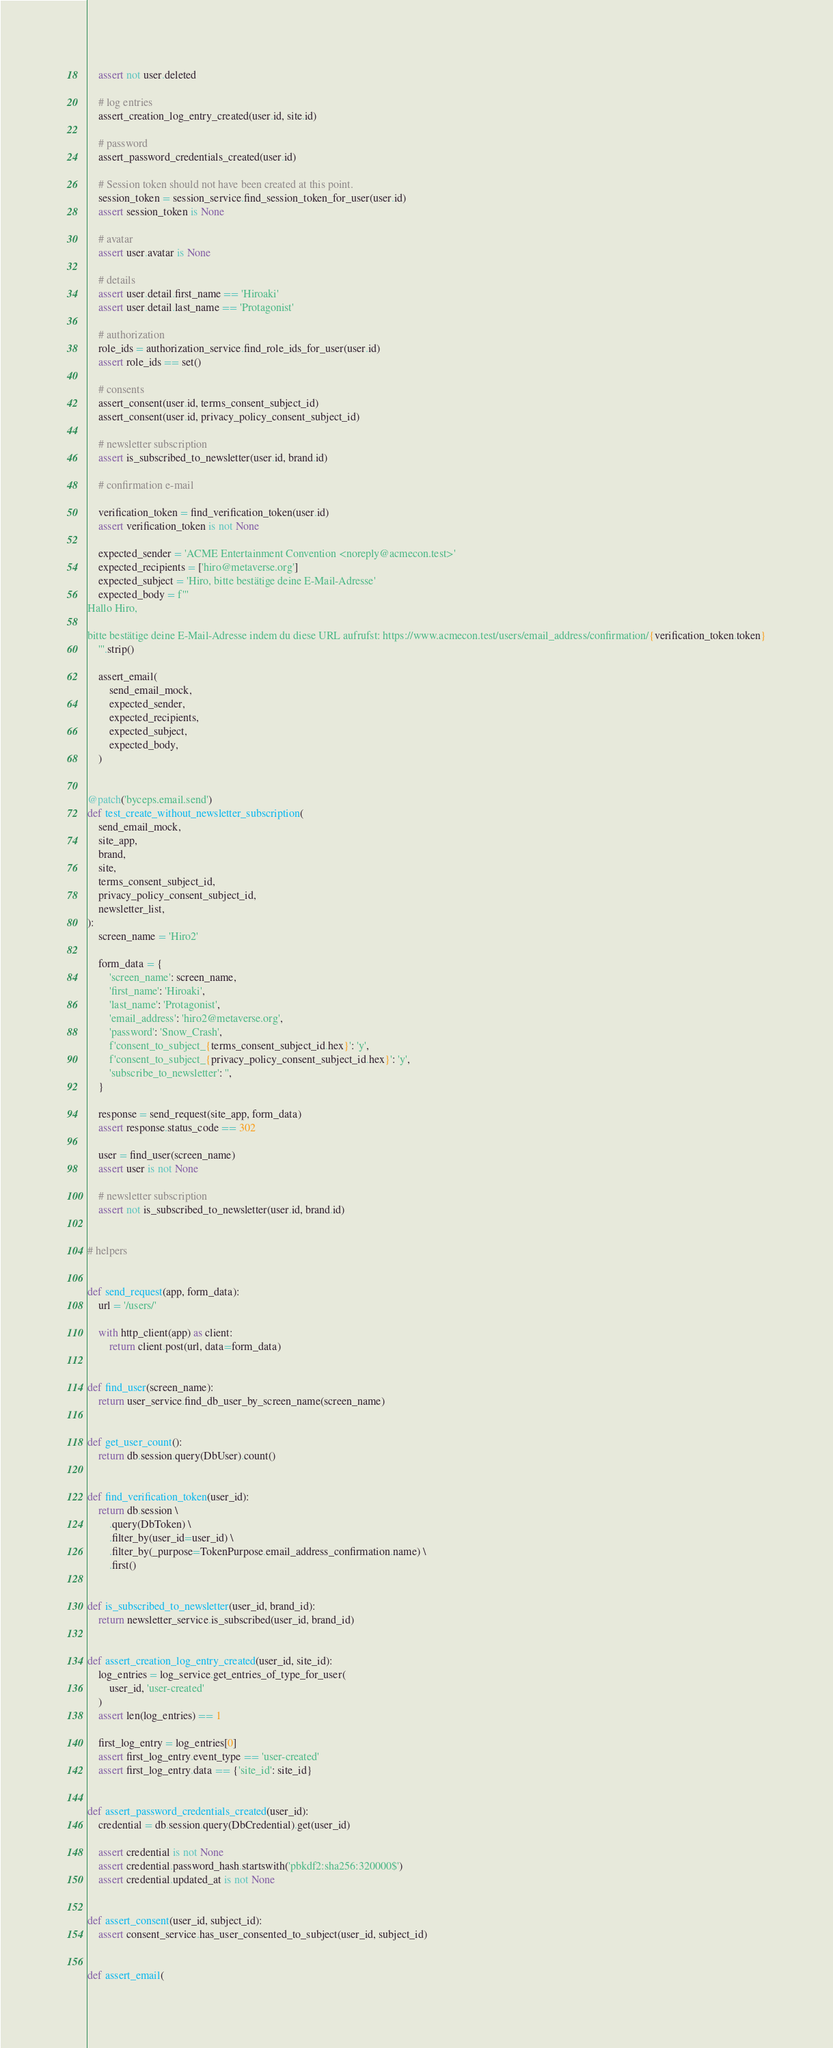<code> <loc_0><loc_0><loc_500><loc_500><_Python_>    assert not user.deleted

    # log entries
    assert_creation_log_entry_created(user.id, site.id)

    # password
    assert_password_credentials_created(user.id)

    # Session token should not have been created at this point.
    session_token = session_service.find_session_token_for_user(user.id)
    assert session_token is None

    # avatar
    assert user.avatar is None

    # details
    assert user.detail.first_name == 'Hiroaki'
    assert user.detail.last_name == 'Protagonist'

    # authorization
    role_ids = authorization_service.find_role_ids_for_user(user.id)
    assert role_ids == set()

    # consents
    assert_consent(user.id, terms_consent_subject_id)
    assert_consent(user.id, privacy_policy_consent_subject_id)

    # newsletter subscription
    assert is_subscribed_to_newsletter(user.id, brand.id)

    # confirmation e-mail

    verification_token = find_verification_token(user.id)
    assert verification_token is not None

    expected_sender = 'ACME Entertainment Convention <noreply@acmecon.test>'
    expected_recipients = ['hiro@metaverse.org']
    expected_subject = 'Hiro, bitte bestätige deine E-Mail-Adresse'
    expected_body = f'''
Hallo Hiro,

bitte bestätige deine E-Mail-Adresse indem du diese URL aufrufst: https://www.acmecon.test/users/email_address/confirmation/{verification_token.token}
    '''.strip()

    assert_email(
        send_email_mock,
        expected_sender,
        expected_recipients,
        expected_subject,
        expected_body,
    )


@patch('byceps.email.send')
def test_create_without_newsletter_subscription(
    send_email_mock,
    site_app,
    brand,
    site,
    terms_consent_subject_id,
    privacy_policy_consent_subject_id,
    newsletter_list,
):
    screen_name = 'Hiro2'

    form_data = {
        'screen_name': screen_name,
        'first_name': 'Hiroaki',
        'last_name': 'Protagonist',
        'email_address': 'hiro2@metaverse.org',
        'password': 'Snow_Crash',
        f'consent_to_subject_{terms_consent_subject_id.hex}': 'y',
        f'consent_to_subject_{privacy_policy_consent_subject_id.hex}': 'y',
        'subscribe_to_newsletter': '',
    }

    response = send_request(site_app, form_data)
    assert response.status_code == 302

    user = find_user(screen_name)
    assert user is not None

    # newsletter subscription
    assert not is_subscribed_to_newsletter(user.id, brand.id)


# helpers


def send_request(app, form_data):
    url = '/users/'

    with http_client(app) as client:
        return client.post(url, data=form_data)


def find_user(screen_name):
    return user_service.find_db_user_by_screen_name(screen_name)


def get_user_count():
    return db.session.query(DbUser).count()


def find_verification_token(user_id):
    return db.session \
        .query(DbToken) \
        .filter_by(user_id=user_id) \
        .filter_by(_purpose=TokenPurpose.email_address_confirmation.name) \
        .first()


def is_subscribed_to_newsletter(user_id, brand_id):
    return newsletter_service.is_subscribed(user_id, brand_id)


def assert_creation_log_entry_created(user_id, site_id):
    log_entries = log_service.get_entries_of_type_for_user(
        user_id, 'user-created'
    )
    assert len(log_entries) == 1

    first_log_entry = log_entries[0]
    assert first_log_entry.event_type == 'user-created'
    assert first_log_entry.data == {'site_id': site_id}


def assert_password_credentials_created(user_id):
    credential = db.session.query(DbCredential).get(user_id)

    assert credential is not None
    assert credential.password_hash.startswith('pbkdf2:sha256:320000$')
    assert credential.updated_at is not None


def assert_consent(user_id, subject_id):
    assert consent_service.has_user_consented_to_subject(user_id, subject_id)


def assert_email(</code> 